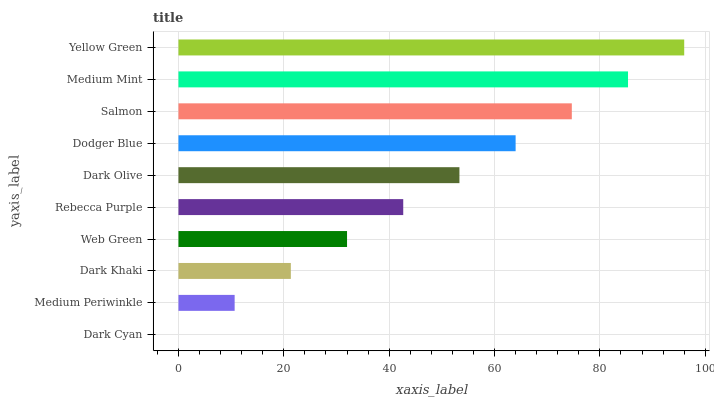Is Dark Cyan the minimum?
Answer yes or no. Yes. Is Yellow Green the maximum?
Answer yes or no. Yes. Is Medium Periwinkle the minimum?
Answer yes or no. No. Is Medium Periwinkle the maximum?
Answer yes or no. No. Is Medium Periwinkle greater than Dark Cyan?
Answer yes or no. Yes. Is Dark Cyan less than Medium Periwinkle?
Answer yes or no. Yes. Is Dark Cyan greater than Medium Periwinkle?
Answer yes or no. No. Is Medium Periwinkle less than Dark Cyan?
Answer yes or no. No. Is Dark Olive the high median?
Answer yes or no. Yes. Is Rebecca Purple the low median?
Answer yes or no. Yes. Is Rebecca Purple the high median?
Answer yes or no. No. Is Medium Mint the low median?
Answer yes or no. No. 